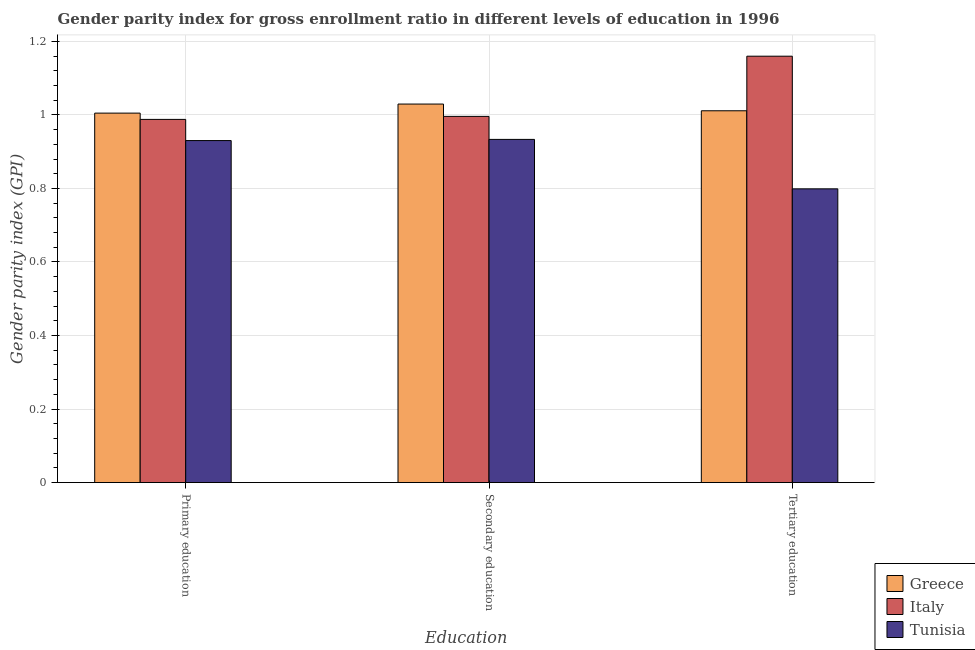How many different coloured bars are there?
Your response must be concise. 3. How many groups of bars are there?
Offer a terse response. 3. Are the number of bars per tick equal to the number of legend labels?
Make the answer very short. Yes. Are the number of bars on each tick of the X-axis equal?
Keep it short and to the point. Yes. What is the gender parity index in primary education in Tunisia?
Your answer should be compact. 0.93. Across all countries, what is the minimum gender parity index in primary education?
Offer a terse response. 0.93. In which country was the gender parity index in primary education maximum?
Provide a succinct answer. Greece. In which country was the gender parity index in tertiary education minimum?
Offer a terse response. Tunisia. What is the total gender parity index in tertiary education in the graph?
Offer a very short reply. 2.97. What is the difference between the gender parity index in primary education in Italy and that in Tunisia?
Your answer should be compact. 0.06. What is the difference between the gender parity index in primary education in Tunisia and the gender parity index in tertiary education in Greece?
Keep it short and to the point. -0.08. What is the average gender parity index in secondary education per country?
Keep it short and to the point. 0.99. What is the difference between the gender parity index in tertiary education and gender parity index in primary education in Tunisia?
Make the answer very short. -0.13. What is the ratio of the gender parity index in tertiary education in Italy to that in Tunisia?
Provide a short and direct response. 1.45. Is the difference between the gender parity index in secondary education in Greece and Tunisia greater than the difference between the gender parity index in primary education in Greece and Tunisia?
Keep it short and to the point. Yes. What is the difference between the highest and the second highest gender parity index in secondary education?
Give a very brief answer. 0.03. What is the difference between the highest and the lowest gender parity index in secondary education?
Your answer should be compact. 0.1. In how many countries, is the gender parity index in tertiary education greater than the average gender parity index in tertiary education taken over all countries?
Offer a terse response. 2. What does the 2nd bar from the left in Primary education represents?
Ensure brevity in your answer.  Italy. What does the 1st bar from the right in Secondary education represents?
Keep it short and to the point. Tunisia. Is it the case that in every country, the sum of the gender parity index in primary education and gender parity index in secondary education is greater than the gender parity index in tertiary education?
Your answer should be compact. Yes. Are all the bars in the graph horizontal?
Provide a short and direct response. No. How many countries are there in the graph?
Give a very brief answer. 3. What is the difference between two consecutive major ticks on the Y-axis?
Your answer should be very brief. 0.2. Does the graph contain any zero values?
Your answer should be very brief. No. Where does the legend appear in the graph?
Your answer should be very brief. Bottom right. How many legend labels are there?
Provide a succinct answer. 3. How are the legend labels stacked?
Make the answer very short. Vertical. What is the title of the graph?
Ensure brevity in your answer.  Gender parity index for gross enrollment ratio in different levels of education in 1996. What is the label or title of the X-axis?
Your response must be concise. Education. What is the label or title of the Y-axis?
Give a very brief answer. Gender parity index (GPI). What is the Gender parity index (GPI) of Italy in Primary education?
Provide a succinct answer. 0.99. What is the Gender parity index (GPI) in Tunisia in Primary education?
Offer a terse response. 0.93. What is the Gender parity index (GPI) in Greece in Secondary education?
Keep it short and to the point. 1.03. What is the Gender parity index (GPI) in Italy in Secondary education?
Your response must be concise. 1. What is the Gender parity index (GPI) of Tunisia in Secondary education?
Give a very brief answer. 0.93. What is the Gender parity index (GPI) in Greece in Tertiary education?
Keep it short and to the point. 1.01. What is the Gender parity index (GPI) in Italy in Tertiary education?
Your answer should be compact. 1.16. What is the Gender parity index (GPI) in Tunisia in Tertiary education?
Offer a very short reply. 0.8. Across all Education, what is the maximum Gender parity index (GPI) of Greece?
Keep it short and to the point. 1.03. Across all Education, what is the maximum Gender parity index (GPI) of Italy?
Keep it short and to the point. 1.16. Across all Education, what is the maximum Gender parity index (GPI) in Tunisia?
Make the answer very short. 0.93. Across all Education, what is the minimum Gender parity index (GPI) in Greece?
Your answer should be compact. 1. Across all Education, what is the minimum Gender parity index (GPI) of Italy?
Your answer should be very brief. 0.99. Across all Education, what is the minimum Gender parity index (GPI) in Tunisia?
Make the answer very short. 0.8. What is the total Gender parity index (GPI) in Greece in the graph?
Provide a succinct answer. 3.05. What is the total Gender parity index (GPI) of Italy in the graph?
Your answer should be compact. 3.14. What is the total Gender parity index (GPI) in Tunisia in the graph?
Ensure brevity in your answer.  2.66. What is the difference between the Gender parity index (GPI) of Greece in Primary education and that in Secondary education?
Your response must be concise. -0.02. What is the difference between the Gender parity index (GPI) in Italy in Primary education and that in Secondary education?
Offer a very short reply. -0.01. What is the difference between the Gender parity index (GPI) of Tunisia in Primary education and that in Secondary education?
Provide a short and direct response. -0. What is the difference between the Gender parity index (GPI) of Greece in Primary education and that in Tertiary education?
Offer a terse response. -0.01. What is the difference between the Gender parity index (GPI) of Italy in Primary education and that in Tertiary education?
Provide a short and direct response. -0.17. What is the difference between the Gender parity index (GPI) of Tunisia in Primary education and that in Tertiary education?
Your response must be concise. 0.13. What is the difference between the Gender parity index (GPI) of Greece in Secondary education and that in Tertiary education?
Your response must be concise. 0.02. What is the difference between the Gender parity index (GPI) in Italy in Secondary education and that in Tertiary education?
Offer a very short reply. -0.16. What is the difference between the Gender parity index (GPI) of Tunisia in Secondary education and that in Tertiary education?
Provide a short and direct response. 0.13. What is the difference between the Gender parity index (GPI) of Greece in Primary education and the Gender parity index (GPI) of Italy in Secondary education?
Make the answer very short. 0.01. What is the difference between the Gender parity index (GPI) in Greece in Primary education and the Gender parity index (GPI) in Tunisia in Secondary education?
Make the answer very short. 0.07. What is the difference between the Gender parity index (GPI) of Italy in Primary education and the Gender parity index (GPI) of Tunisia in Secondary education?
Your response must be concise. 0.05. What is the difference between the Gender parity index (GPI) in Greece in Primary education and the Gender parity index (GPI) in Italy in Tertiary education?
Provide a succinct answer. -0.15. What is the difference between the Gender parity index (GPI) of Greece in Primary education and the Gender parity index (GPI) of Tunisia in Tertiary education?
Your answer should be very brief. 0.21. What is the difference between the Gender parity index (GPI) of Italy in Primary education and the Gender parity index (GPI) of Tunisia in Tertiary education?
Keep it short and to the point. 0.19. What is the difference between the Gender parity index (GPI) in Greece in Secondary education and the Gender parity index (GPI) in Italy in Tertiary education?
Ensure brevity in your answer.  -0.13. What is the difference between the Gender parity index (GPI) in Greece in Secondary education and the Gender parity index (GPI) in Tunisia in Tertiary education?
Your answer should be very brief. 0.23. What is the difference between the Gender parity index (GPI) of Italy in Secondary education and the Gender parity index (GPI) of Tunisia in Tertiary education?
Your answer should be very brief. 0.2. What is the average Gender parity index (GPI) in Greece per Education?
Your response must be concise. 1.02. What is the average Gender parity index (GPI) in Italy per Education?
Your response must be concise. 1.05. What is the average Gender parity index (GPI) in Tunisia per Education?
Offer a terse response. 0.89. What is the difference between the Gender parity index (GPI) of Greece and Gender parity index (GPI) of Italy in Primary education?
Offer a terse response. 0.02. What is the difference between the Gender parity index (GPI) of Greece and Gender parity index (GPI) of Tunisia in Primary education?
Ensure brevity in your answer.  0.07. What is the difference between the Gender parity index (GPI) of Italy and Gender parity index (GPI) of Tunisia in Primary education?
Provide a short and direct response. 0.06. What is the difference between the Gender parity index (GPI) of Greece and Gender parity index (GPI) of Italy in Secondary education?
Offer a terse response. 0.03. What is the difference between the Gender parity index (GPI) in Greece and Gender parity index (GPI) in Tunisia in Secondary education?
Ensure brevity in your answer.  0.1. What is the difference between the Gender parity index (GPI) of Italy and Gender parity index (GPI) of Tunisia in Secondary education?
Your answer should be compact. 0.06. What is the difference between the Gender parity index (GPI) in Greece and Gender parity index (GPI) in Italy in Tertiary education?
Your answer should be compact. -0.15. What is the difference between the Gender parity index (GPI) of Greece and Gender parity index (GPI) of Tunisia in Tertiary education?
Your answer should be very brief. 0.21. What is the difference between the Gender parity index (GPI) in Italy and Gender parity index (GPI) in Tunisia in Tertiary education?
Your response must be concise. 0.36. What is the ratio of the Gender parity index (GPI) of Greece in Primary education to that in Secondary education?
Your answer should be compact. 0.98. What is the ratio of the Gender parity index (GPI) in Italy in Primary education to that in Tertiary education?
Keep it short and to the point. 0.85. What is the ratio of the Gender parity index (GPI) in Tunisia in Primary education to that in Tertiary education?
Provide a short and direct response. 1.16. What is the ratio of the Gender parity index (GPI) of Greece in Secondary education to that in Tertiary education?
Provide a short and direct response. 1.02. What is the ratio of the Gender parity index (GPI) of Italy in Secondary education to that in Tertiary education?
Keep it short and to the point. 0.86. What is the ratio of the Gender parity index (GPI) of Tunisia in Secondary education to that in Tertiary education?
Ensure brevity in your answer.  1.17. What is the difference between the highest and the second highest Gender parity index (GPI) of Greece?
Give a very brief answer. 0.02. What is the difference between the highest and the second highest Gender parity index (GPI) of Italy?
Provide a short and direct response. 0.16. What is the difference between the highest and the second highest Gender parity index (GPI) in Tunisia?
Your answer should be very brief. 0. What is the difference between the highest and the lowest Gender parity index (GPI) of Greece?
Your answer should be very brief. 0.02. What is the difference between the highest and the lowest Gender parity index (GPI) in Italy?
Offer a very short reply. 0.17. What is the difference between the highest and the lowest Gender parity index (GPI) of Tunisia?
Give a very brief answer. 0.13. 